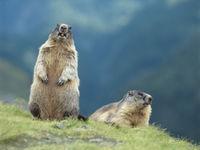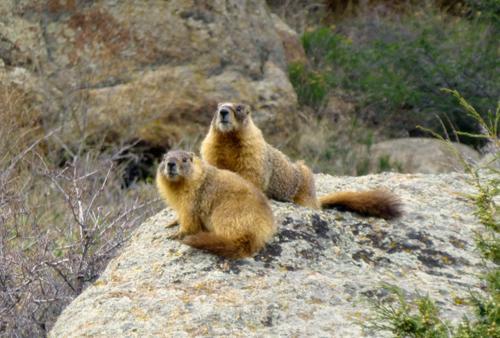The first image is the image on the left, the second image is the image on the right. Considering the images on both sides, is "Two pairs of ground hogs are kissing." valid? Answer yes or no. No. The first image is the image on the left, the second image is the image on the right. Considering the images on both sides, is "The marmots are touching in each image." valid? Answer yes or no. No. 